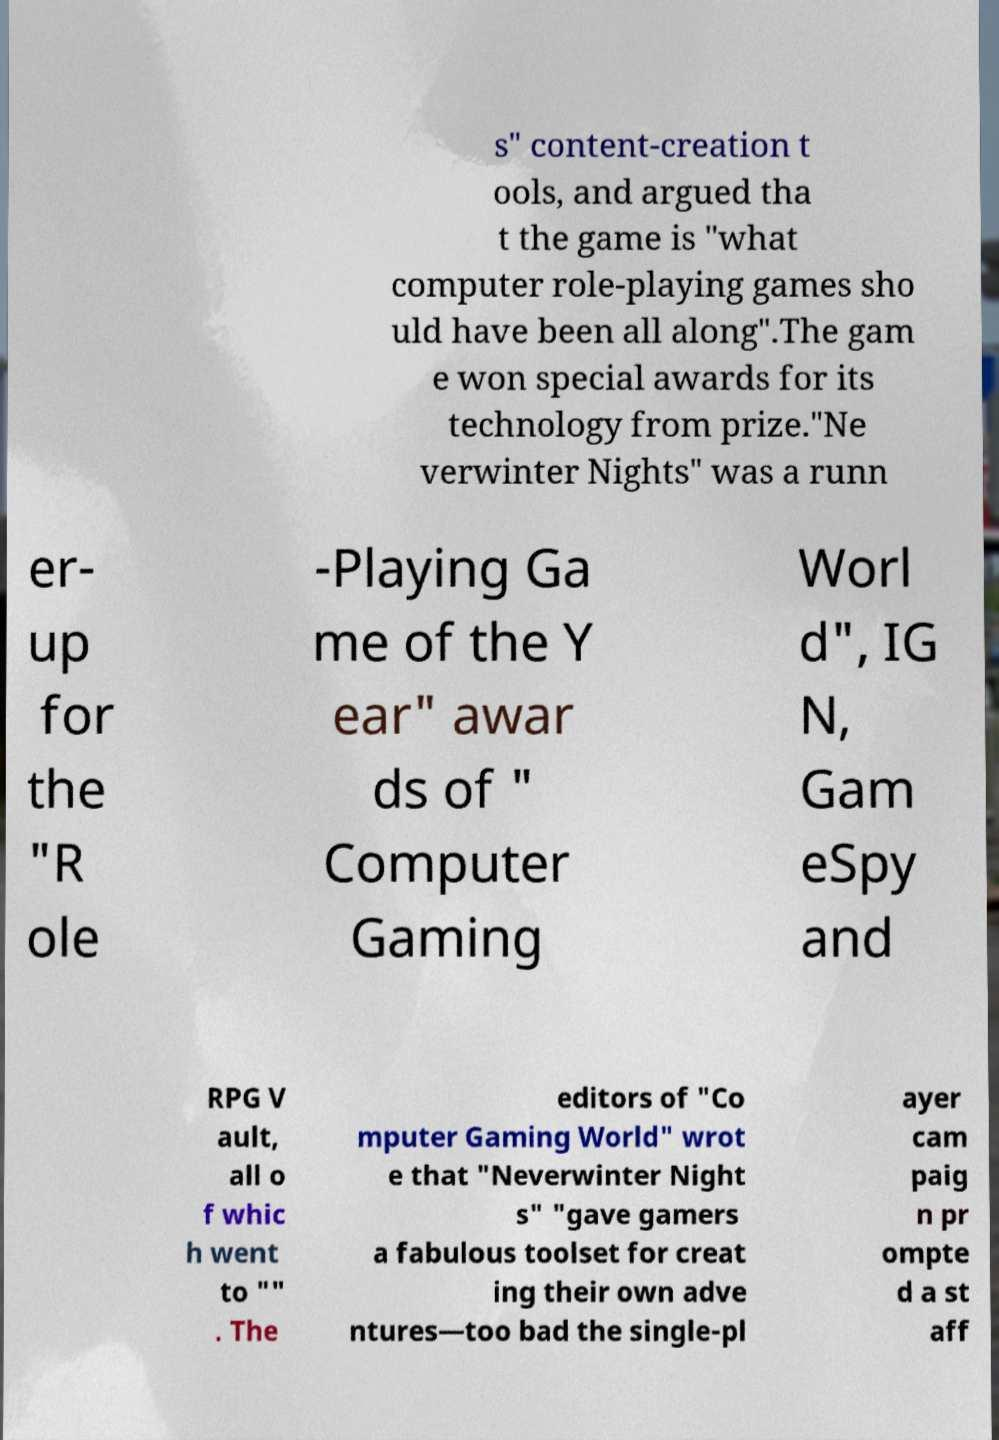Can you accurately transcribe the text from the provided image for me? s" content-creation t ools, and argued tha t the game is "what computer role-playing games sho uld have been all along".The gam e won special awards for its technology from prize."Ne verwinter Nights" was a runn er- up for the "R ole -Playing Ga me of the Y ear" awar ds of " Computer Gaming Worl d", IG N, Gam eSpy and RPG V ault, all o f whic h went to "" . The editors of "Co mputer Gaming World" wrot e that "Neverwinter Night s" "gave gamers a fabulous toolset for creat ing their own adve ntures—too bad the single-pl ayer cam paig n pr ompte d a st aff 